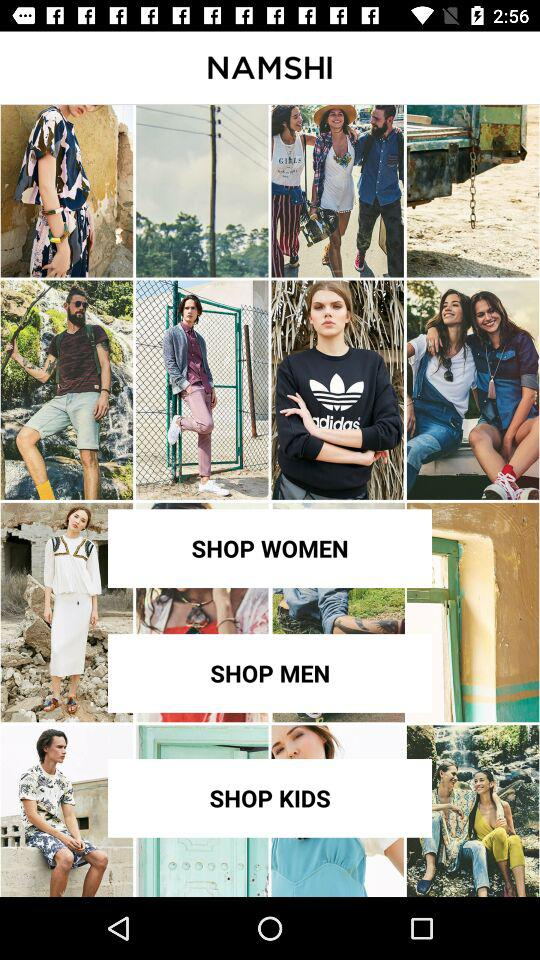What is the application name? The application name is "NAMSHI". 